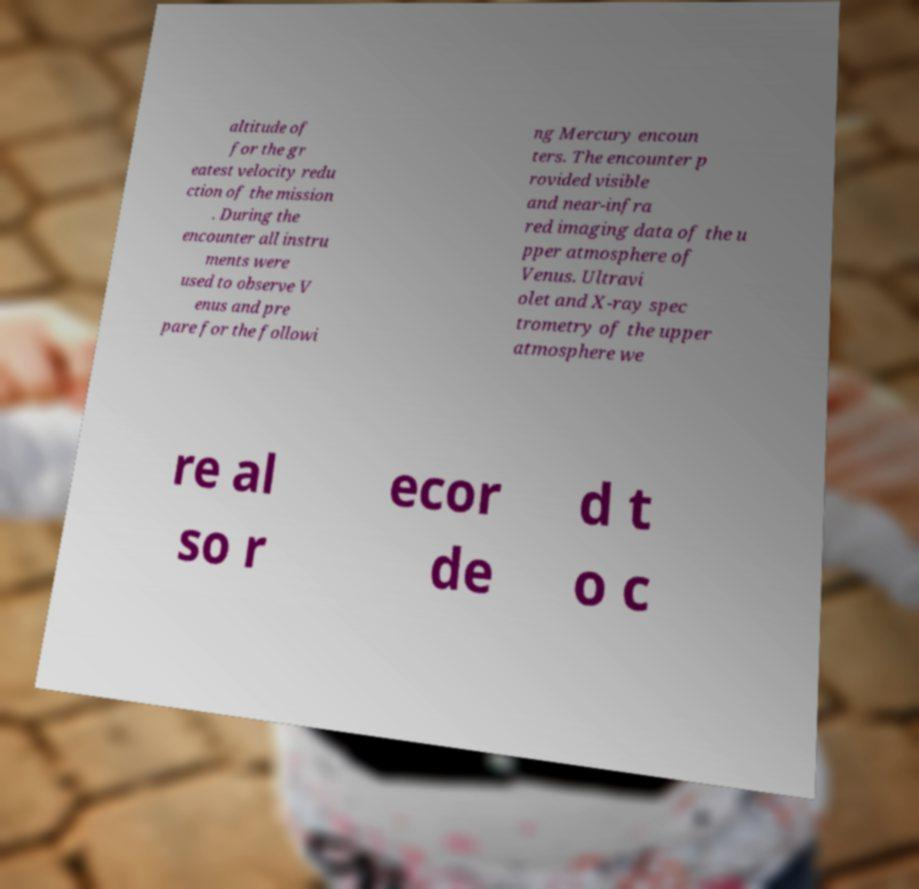Can you read and provide the text displayed in the image?This photo seems to have some interesting text. Can you extract and type it out for me? altitude of for the gr eatest velocity redu ction of the mission . During the encounter all instru ments were used to observe V enus and pre pare for the followi ng Mercury encoun ters. The encounter p rovided visible and near-infra red imaging data of the u pper atmosphere of Venus. Ultravi olet and X-ray spec trometry of the upper atmosphere we re al so r ecor de d t o c 